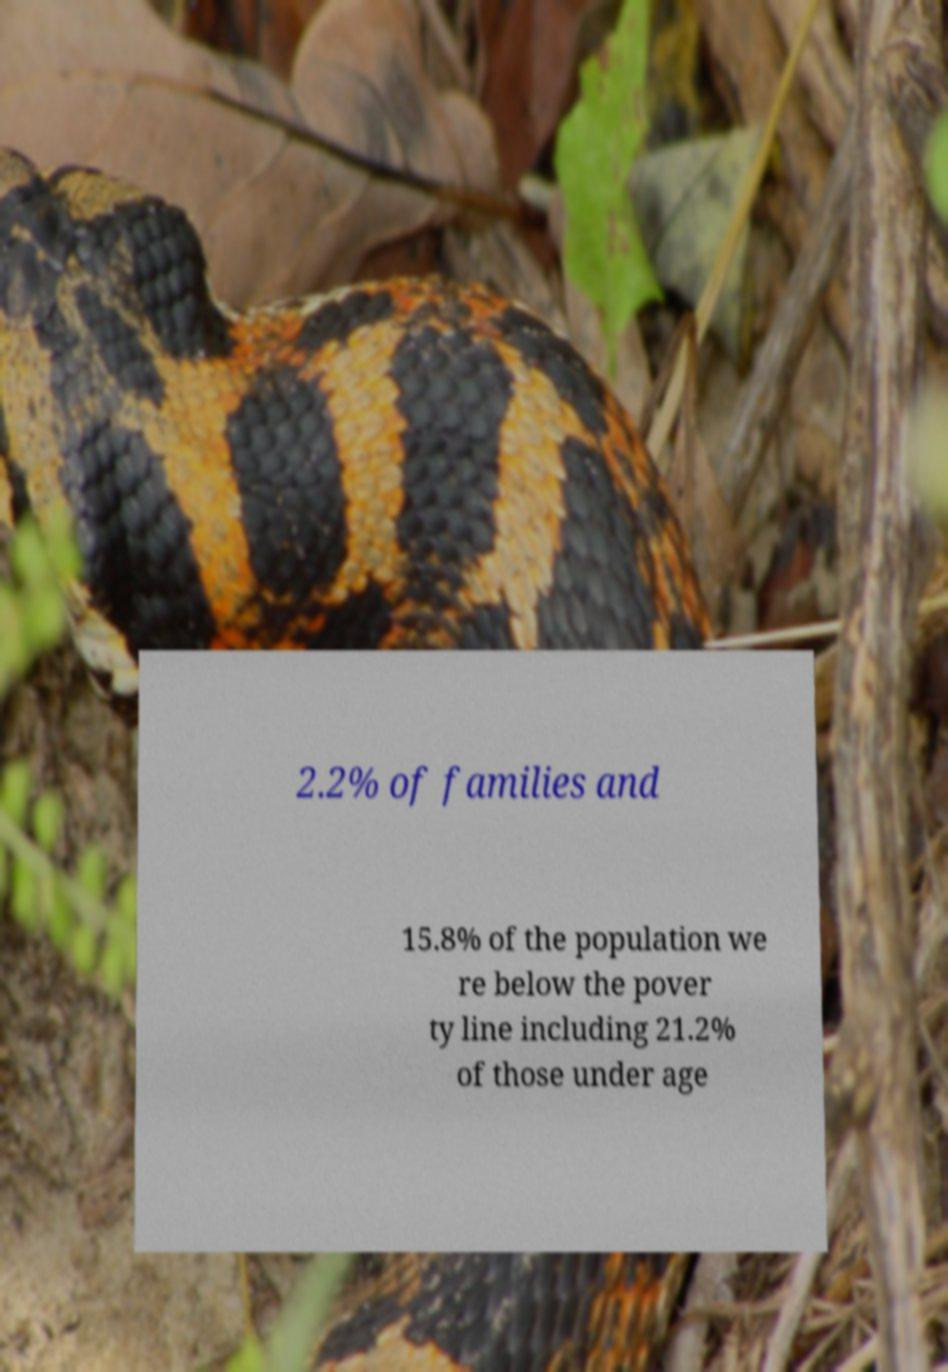There's text embedded in this image that I need extracted. Can you transcribe it verbatim? 2.2% of families and 15.8% of the population we re below the pover ty line including 21.2% of those under age 